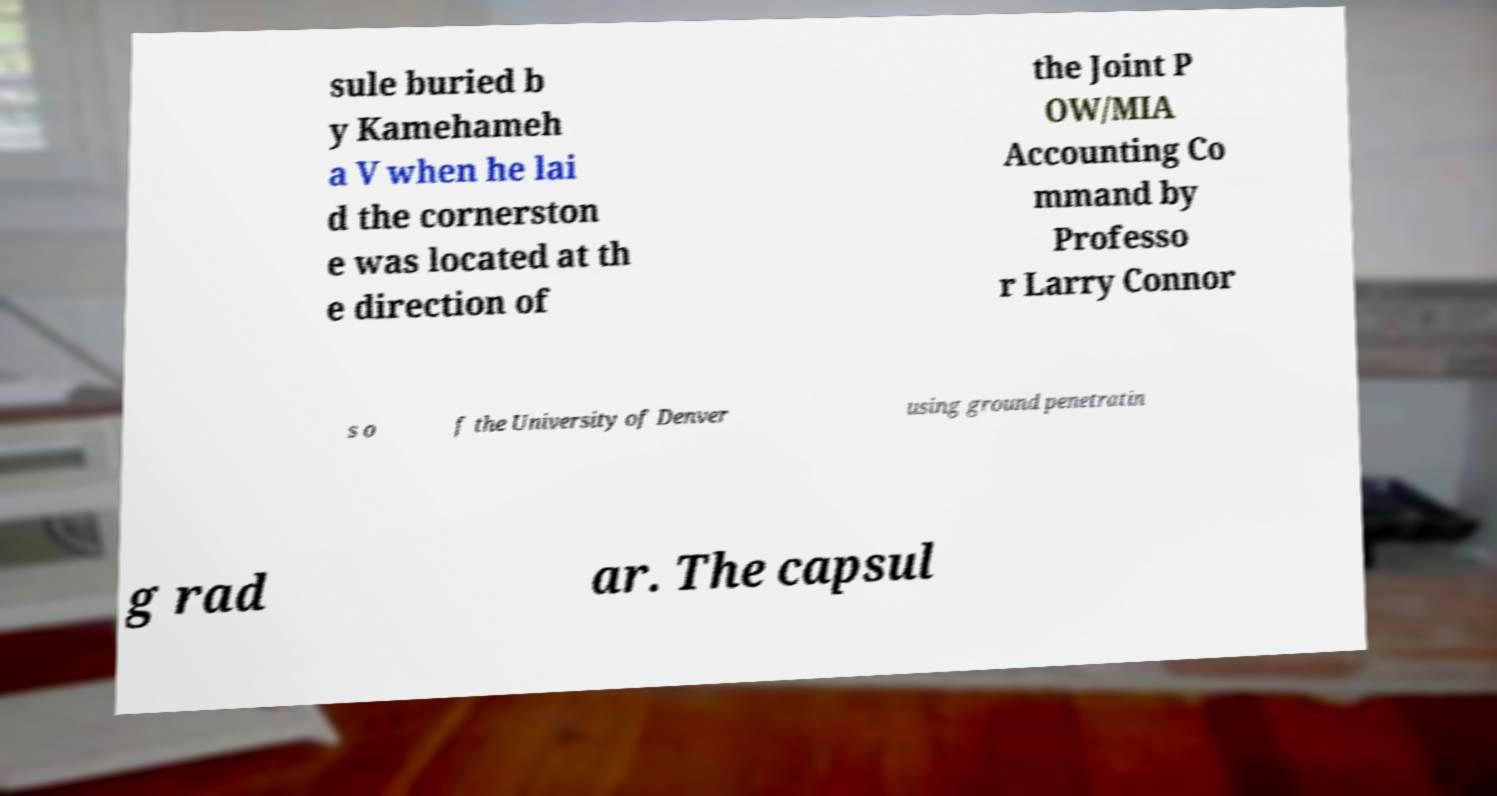I need the written content from this picture converted into text. Can you do that? sule buried b y Kamehameh a V when he lai d the cornerston e was located at th e direction of the Joint P OW/MIA Accounting Co mmand by Professo r Larry Connor s o f the University of Denver using ground penetratin g rad ar. The capsul 